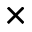Convert formula to latex. <formula><loc_0><loc_0><loc_500><loc_500>\times</formula> 